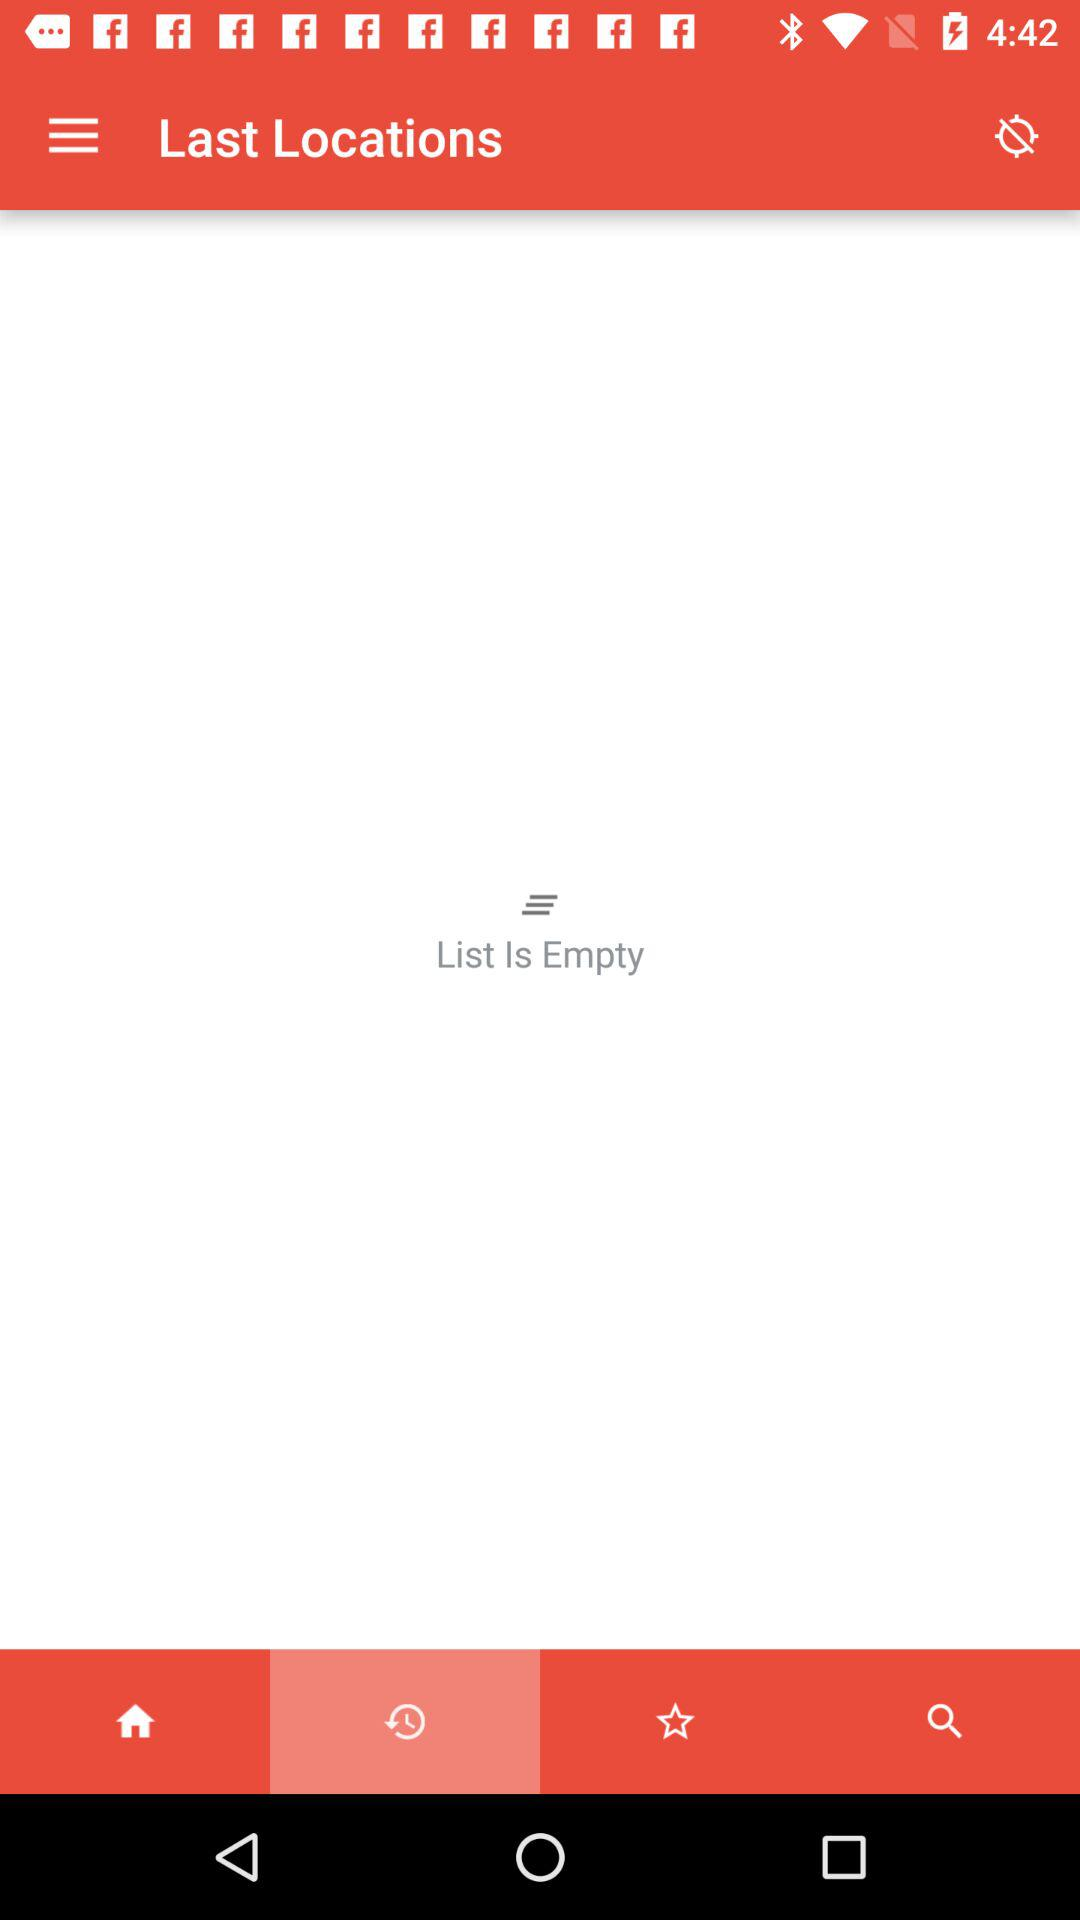Which tab is selected? The selected tab is the "Recents". 